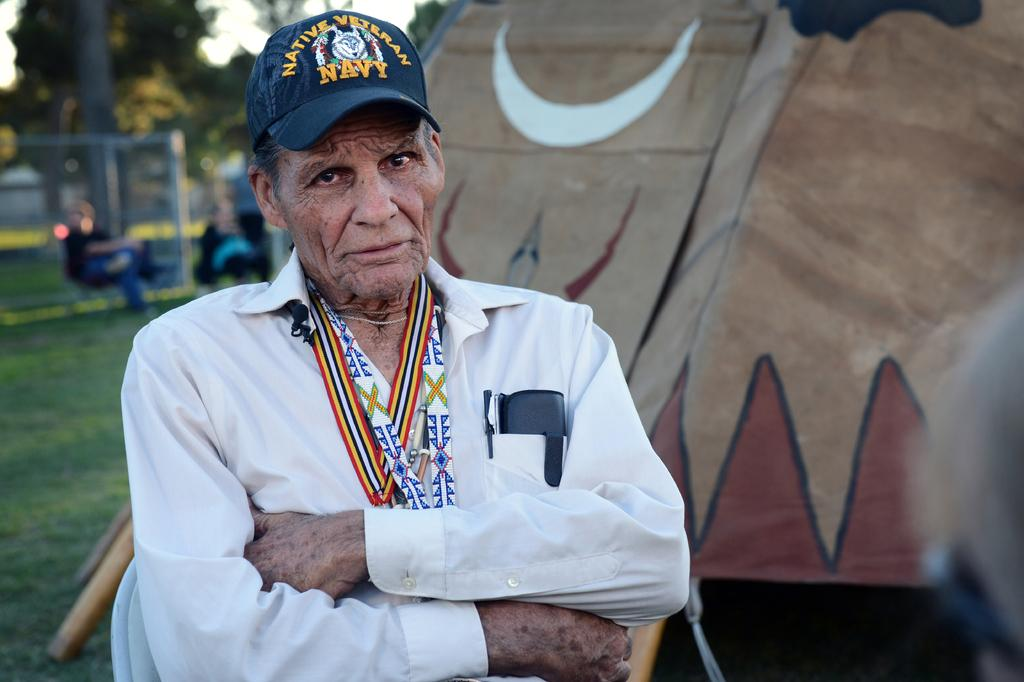<image>
Give a short and clear explanation of the subsequent image. An elderly man in a Native Veteran Navy hat. 